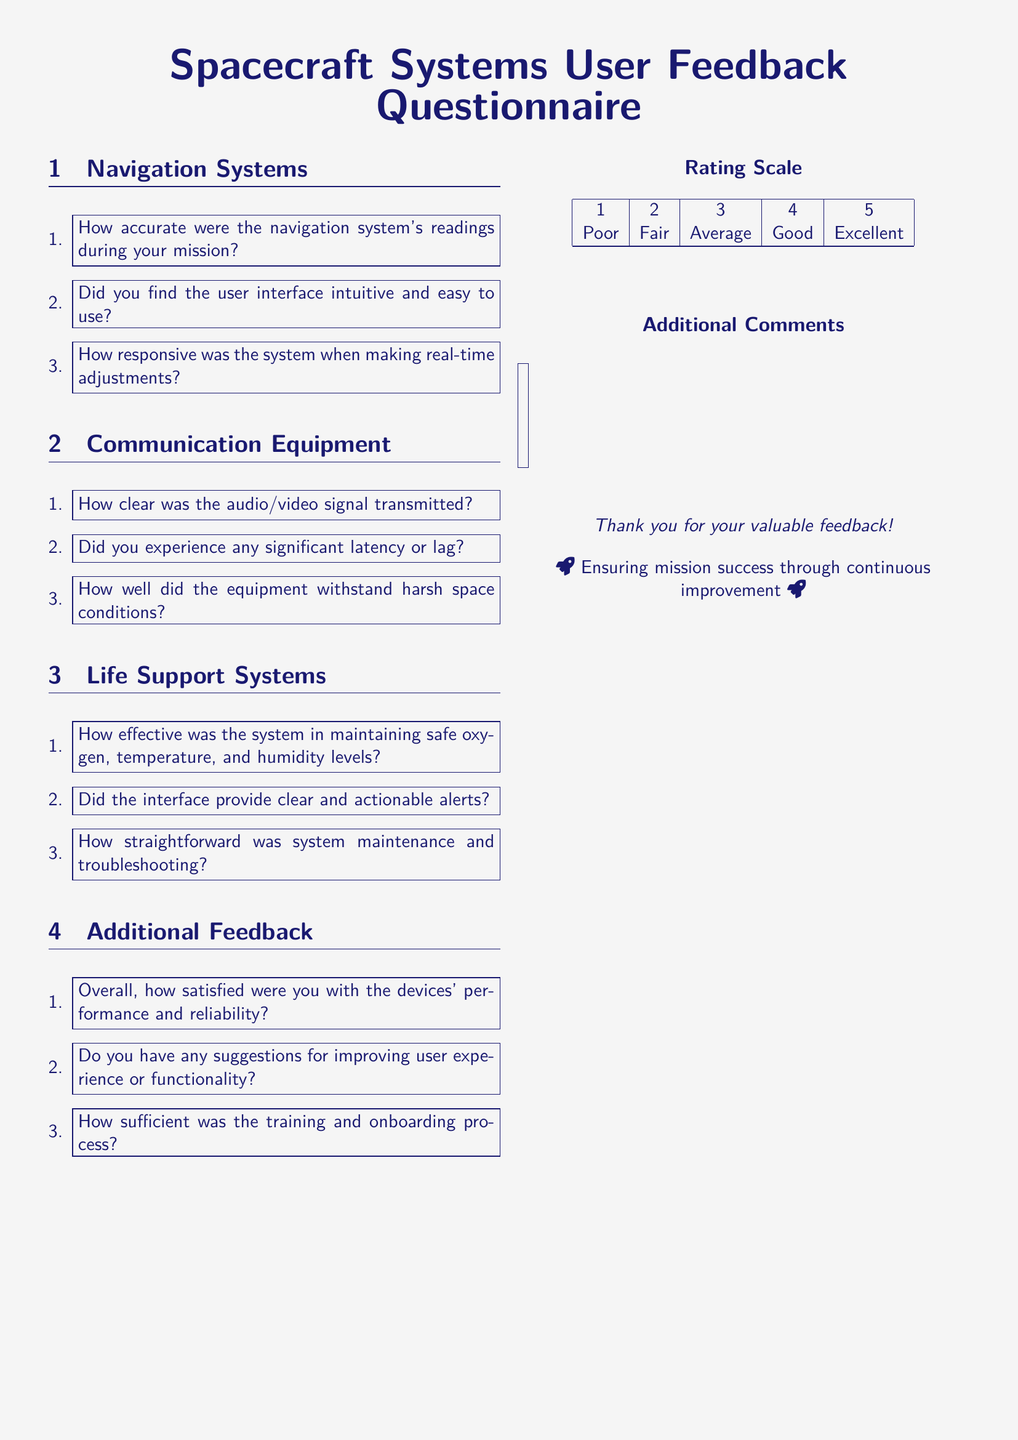What is the title of the document? The title of the document is highlighted at the top in a larger font, indicating its purpose.
Answer: Spacecraft Systems User Feedback Questionnaire How many sections are there in the questionnaire? The document features distinct sections, representing different systems or areas of feedback.
Answer: Four What is the first question under Navigation Systems? The first question in the Navigation Systems section seeks specific feedback about the system’s performance during the mission.
Answer: How accurate were the navigation system's readings during your mission? What is the rating scale described in the document? The document presents a rating scale that summarizes user satisfaction levels with devices and their performance.
Answer: 1 to 5 What color is used for the main text? The main color scheme of the document is designed to reflect a space theme, particularly in text representation.
Answer: Space blue What kind of feedback is sought in the Additional Feedback section? This section aims to gather user insights about overall satisfaction and improvements for the devices.
Answer: Suggestions for improving user experience or functionality 